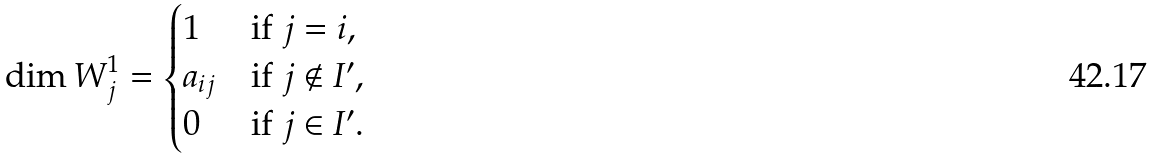<formula> <loc_0><loc_0><loc_500><loc_500>\dim W ^ { 1 } _ { j } = \begin{cases} 1 & \text {if $j=i$} , \\ a _ { i j } & \text {if $j\notin I^{\prime}$} , \\ 0 & \text {if $j\in I^{\prime}$} . \end{cases}</formula> 